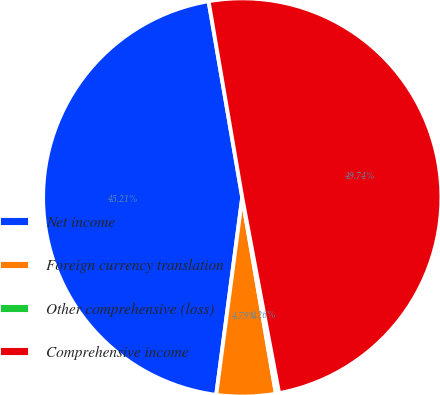Convert chart. <chart><loc_0><loc_0><loc_500><loc_500><pie_chart><fcel>Net income<fcel>Foreign currency translation<fcel>Other comprehensive (loss)<fcel>Comprehensive income<nl><fcel>45.21%<fcel>4.79%<fcel>0.26%<fcel>49.74%<nl></chart> 